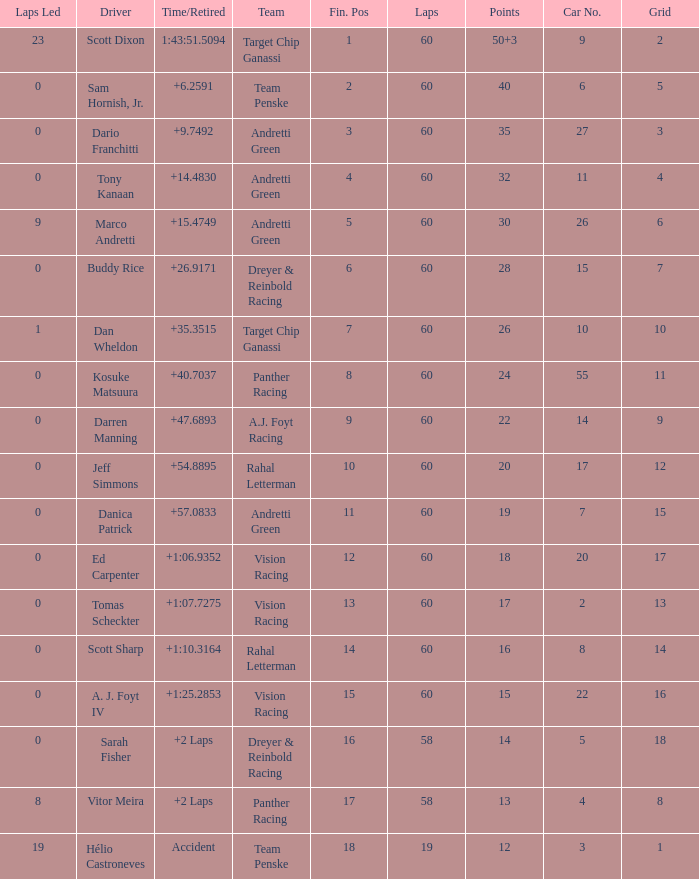Name the laps for 18 pointss 60.0. 